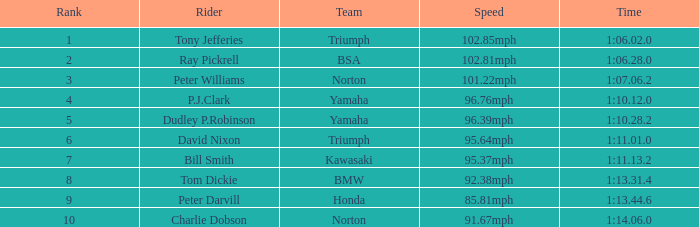At 96.76mph speed, what is the Time? 1:10.12.0. 